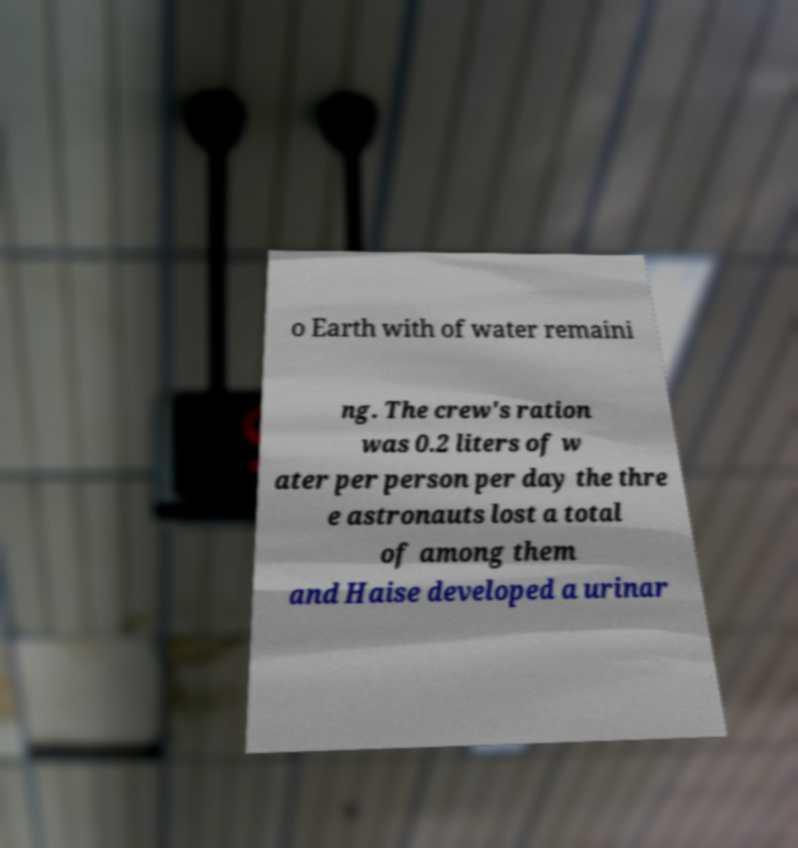Can you accurately transcribe the text from the provided image for me? o Earth with of water remaini ng. The crew's ration was 0.2 liters of w ater per person per day the thre e astronauts lost a total of among them and Haise developed a urinar 